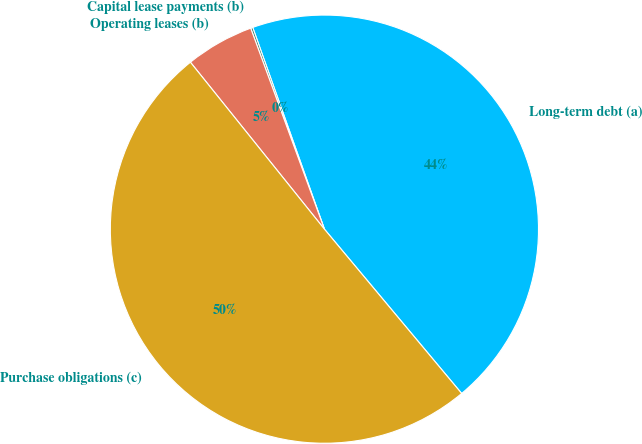Convert chart to OTSL. <chart><loc_0><loc_0><loc_500><loc_500><pie_chart><fcel>Long-term debt (a)<fcel>Capital lease payments (b)<fcel>Operating leases (b)<fcel>Purchase obligations (c)<nl><fcel>44.36%<fcel>0.16%<fcel>5.17%<fcel>50.31%<nl></chart> 